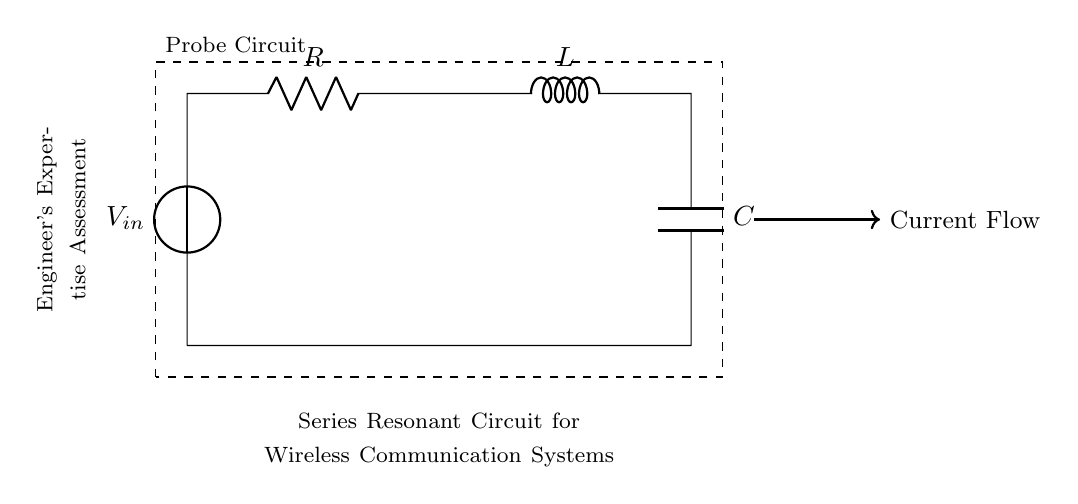What components are present in the circuit? The circuit diagram includes a voltage source, a resistor, an inductor, and a capacitor. These components are identified by their respective symbols in the diagram.
Answer: Voltage source, resistor, inductor, capacitor What is the function of the inductor in this circuit? The inductor stores energy in a magnetic field when current flows through it, contributing to the resonant behavior of the circuit when combined with the capacitor.
Answer: Energy storage What is the purpose of the series resonant circuit? The purpose is to create a circuit that can resonate at a specific frequency, which is useful in wireless communication systems for filtering and tuning signals.
Answer: Frequency resonance How does the current flow in the circuit? Current flows from the voltage source through the resistor, then through the inductor and capacitor in series before returning to the source. This serial arrangement dictates the current's path in the circuit.
Answer: From voltage source, through components, back to source If the resistance increases, what happens to the circuit's quality factor? An increase in resistance decreases the quality factor of the circuit, leading to broader resonance peaks and reduced selectivity of frequencies. This is because the quality factor is inversely proportional to the resistance in a series resonant circuit.
Answer: Decreases At what frequency does resonance occur in this circuit? The resonance frequency occurs when the inductive reactance equals the capacitive reactance, which can be determined using the formula for resonance frequency in a series circuit, which is one over the square root of the product of inductance and capacitance.
Answer: Calculated frequency 